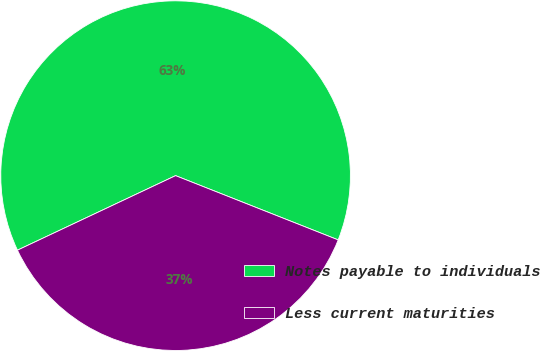<chart> <loc_0><loc_0><loc_500><loc_500><pie_chart><fcel>Notes payable to individuals<fcel>Less current maturities<nl><fcel>63.0%<fcel>37.0%<nl></chart> 